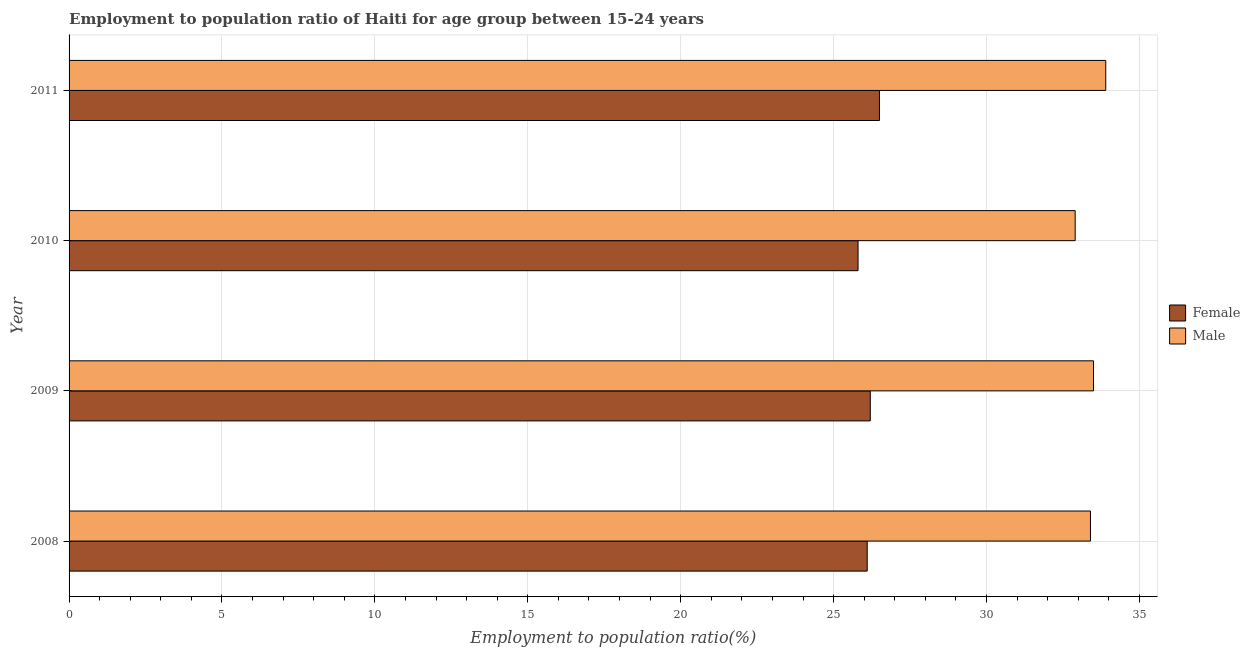How many different coloured bars are there?
Make the answer very short. 2. In how many cases, is the number of bars for a given year not equal to the number of legend labels?
Provide a succinct answer. 0. What is the employment to population ratio(male) in 2010?
Give a very brief answer. 32.9. Across all years, what is the maximum employment to population ratio(male)?
Your answer should be compact. 33.9. Across all years, what is the minimum employment to population ratio(female)?
Give a very brief answer. 25.8. What is the total employment to population ratio(male) in the graph?
Give a very brief answer. 133.7. What is the difference between the employment to population ratio(female) in 2009 and that in 2010?
Make the answer very short. 0.4. What is the difference between the employment to population ratio(male) in 2008 and the employment to population ratio(female) in 2011?
Keep it short and to the point. 6.9. What is the average employment to population ratio(male) per year?
Provide a short and direct response. 33.42. In the year 2010, what is the difference between the employment to population ratio(male) and employment to population ratio(female)?
Keep it short and to the point. 7.1. Is the employment to population ratio(male) in 2008 less than that in 2009?
Give a very brief answer. Yes. Is the difference between the employment to population ratio(female) in 2009 and 2011 greater than the difference between the employment to population ratio(male) in 2009 and 2011?
Ensure brevity in your answer.  Yes. What is the difference between the highest and the second highest employment to population ratio(female)?
Offer a terse response. 0.3. What is the difference between the highest and the lowest employment to population ratio(male)?
Offer a terse response. 1. Are all the bars in the graph horizontal?
Ensure brevity in your answer.  Yes. What is the difference between two consecutive major ticks on the X-axis?
Your response must be concise. 5. Does the graph contain grids?
Provide a short and direct response. Yes. How many legend labels are there?
Your response must be concise. 2. How are the legend labels stacked?
Your response must be concise. Vertical. What is the title of the graph?
Your answer should be very brief. Employment to population ratio of Haiti for age group between 15-24 years. Does "Agricultural land" appear as one of the legend labels in the graph?
Your response must be concise. No. What is the Employment to population ratio(%) of Female in 2008?
Your response must be concise. 26.1. What is the Employment to population ratio(%) of Male in 2008?
Your answer should be compact. 33.4. What is the Employment to population ratio(%) of Female in 2009?
Offer a terse response. 26.2. What is the Employment to population ratio(%) in Male in 2009?
Offer a very short reply. 33.5. What is the Employment to population ratio(%) of Female in 2010?
Provide a short and direct response. 25.8. What is the Employment to population ratio(%) of Male in 2010?
Your answer should be compact. 32.9. What is the Employment to population ratio(%) of Male in 2011?
Give a very brief answer. 33.9. Across all years, what is the maximum Employment to population ratio(%) in Female?
Your answer should be very brief. 26.5. Across all years, what is the maximum Employment to population ratio(%) of Male?
Ensure brevity in your answer.  33.9. Across all years, what is the minimum Employment to population ratio(%) of Female?
Ensure brevity in your answer.  25.8. Across all years, what is the minimum Employment to population ratio(%) of Male?
Offer a very short reply. 32.9. What is the total Employment to population ratio(%) of Female in the graph?
Your answer should be very brief. 104.6. What is the total Employment to population ratio(%) in Male in the graph?
Give a very brief answer. 133.7. What is the difference between the Employment to population ratio(%) of Female in 2008 and that in 2010?
Your answer should be compact. 0.3. What is the difference between the Employment to population ratio(%) in Male in 2008 and that in 2010?
Ensure brevity in your answer.  0.5. What is the difference between the Employment to population ratio(%) in Male in 2008 and that in 2011?
Provide a short and direct response. -0.5. What is the difference between the Employment to population ratio(%) of Female in 2009 and that in 2010?
Provide a succinct answer. 0.4. What is the difference between the Employment to population ratio(%) in Female in 2009 and that in 2011?
Keep it short and to the point. -0.3. What is the difference between the Employment to population ratio(%) in Male in 2009 and that in 2011?
Provide a succinct answer. -0.4. What is the difference between the Employment to population ratio(%) of Female in 2010 and that in 2011?
Keep it short and to the point. -0.7. What is the difference between the Employment to population ratio(%) in Male in 2010 and that in 2011?
Provide a short and direct response. -1. What is the difference between the Employment to population ratio(%) of Female in 2008 and the Employment to population ratio(%) of Male in 2010?
Provide a succinct answer. -6.8. What is the difference between the Employment to population ratio(%) of Female in 2009 and the Employment to population ratio(%) of Male in 2010?
Give a very brief answer. -6.7. What is the difference between the Employment to population ratio(%) of Female in 2009 and the Employment to population ratio(%) of Male in 2011?
Your response must be concise. -7.7. What is the average Employment to population ratio(%) of Female per year?
Your answer should be very brief. 26.15. What is the average Employment to population ratio(%) of Male per year?
Your answer should be compact. 33.42. In the year 2008, what is the difference between the Employment to population ratio(%) of Female and Employment to population ratio(%) of Male?
Your response must be concise. -7.3. In the year 2010, what is the difference between the Employment to population ratio(%) of Female and Employment to population ratio(%) of Male?
Give a very brief answer. -7.1. In the year 2011, what is the difference between the Employment to population ratio(%) of Female and Employment to population ratio(%) of Male?
Your answer should be compact. -7.4. What is the ratio of the Employment to population ratio(%) of Male in 2008 to that in 2009?
Make the answer very short. 1. What is the ratio of the Employment to population ratio(%) in Female in 2008 to that in 2010?
Your answer should be very brief. 1.01. What is the ratio of the Employment to population ratio(%) of Male in 2008 to that in 2010?
Make the answer very short. 1.02. What is the ratio of the Employment to population ratio(%) of Female in 2008 to that in 2011?
Keep it short and to the point. 0.98. What is the ratio of the Employment to population ratio(%) in Female in 2009 to that in 2010?
Give a very brief answer. 1.02. What is the ratio of the Employment to population ratio(%) in Male in 2009 to that in 2010?
Your answer should be very brief. 1.02. What is the ratio of the Employment to population ratio(%) in Female in 2009 to that in 2011?
Provide a short and direct response. 0.99. What is the ratio of the Employment to population ratio(%) of Female in 2010 to that in 2011?
Provide a succinct answer. 0.97. What is the ratio of the Employment to population ratio(%) of Male in 2010 to that in 2011?
Your answer should be very brief. 0.97. What is the difference between the highest and the second highest Employment to population ratio(%) of Male?
Offer a very short reply. 0.4. What is the difference between the highest and the lowest Employment to population ratio(%) in Male?
Give a very brief answer. 1. 